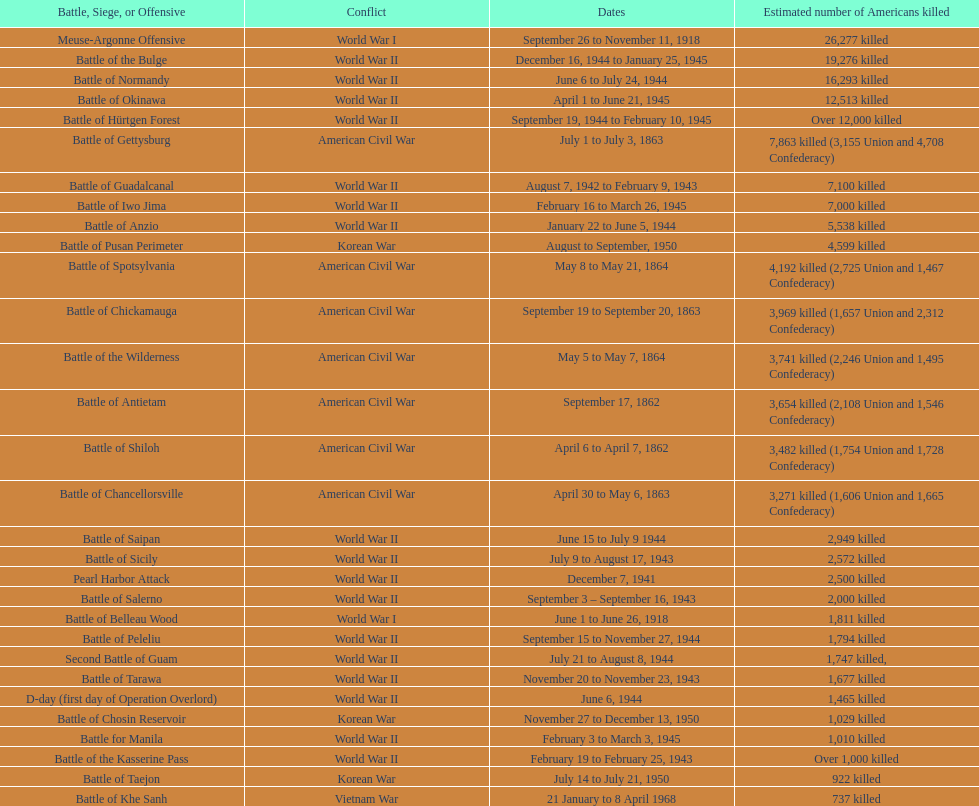How many battles resulted between 3,000 and 4,200 estimated americans killed? 6. 